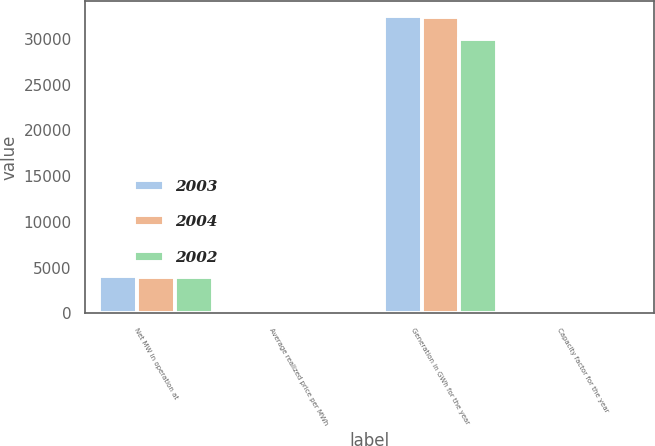<chart> <loc_0><loc_0><loc_500><loc_500><stacked_bar_chart><ecel><fcel>Net MW in operation at<fcel>Average realized price per MWh<fcel>Generation in GWh for the year<fcel>Capacity factor for the year<nl><fcel>2003<fcel>4058<fcel>41.26<fcel>32524<fcel>92<nl><fcel>2004<fcel>4001<fcel>39.38<fcel>32379<fcel>92<nl><fcel>2002<fcel>3955<fcel>40.07<fcel>29953<fcel>93<nl></chart> 